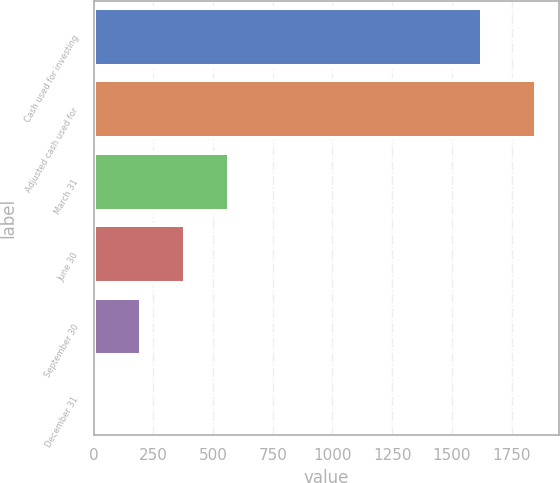Convert chart to OTSL. <chart><loc_0><loc_0><loc_500><loc_500><bar_chart><fcel>Cash used for investing<fcel>Adjusted cash used for<fcel>March 31<fcel>June 30<fcel>September 30<fcel>December 31<nl><fcel>1624.7<fcel>1854.1<fcel>564.98<fcel>380.82<fcel>196.66<fcel>12.5<nl></chart> 